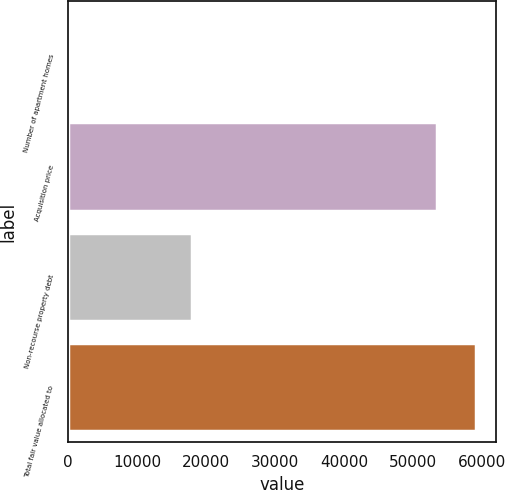Convert chart to OTSL. <chart><loc_0><loc_0><loc_500><loc_500><bar_chart><fcel>Number of apartment homes<fcel>Acquisition price<fcel>Non-recourse property debt<fcel>Total fair value allocated to<nl><fcel>134<fcel>53575<fcel>18022.2<fcel>59151.2<nl></chart> 